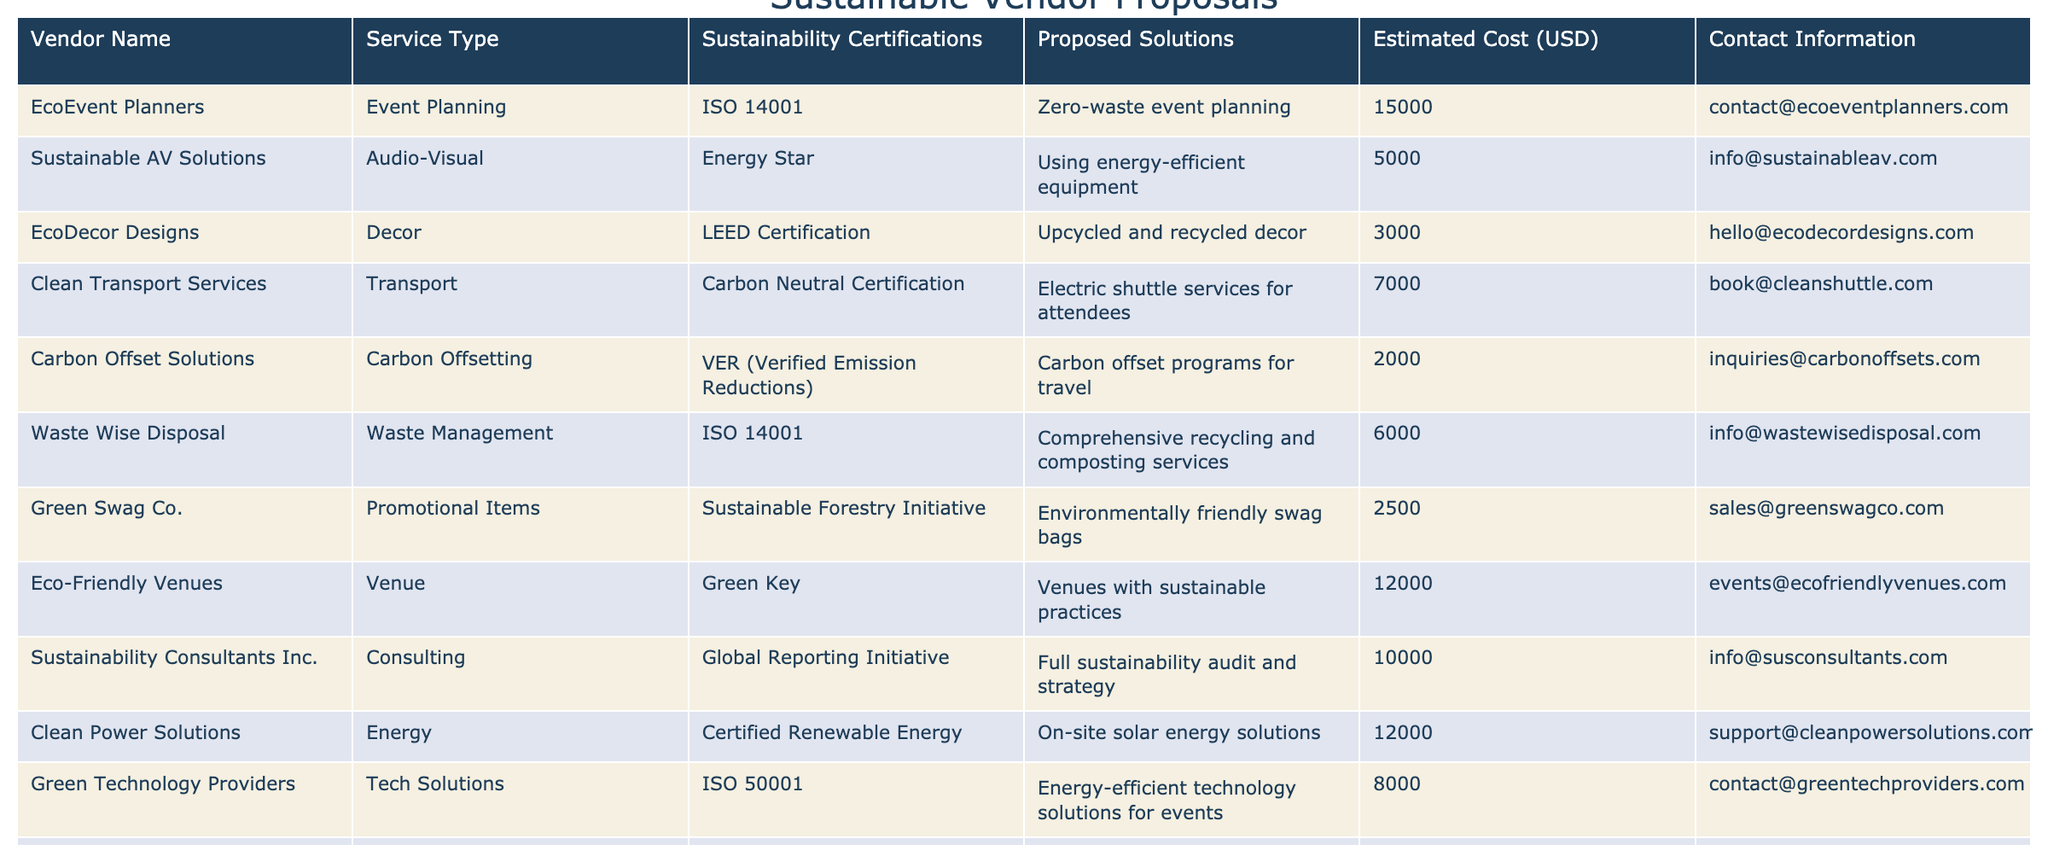What is the estimated cost of the EcoFriendly Venues service? In the table, I find the row for Eco-Friendly Venues and see the estimated cost is listed as 12000 USD.
Answer: 12000 USD What certifications does Waste Wise Disposal hold? By examining the Waste Wise Disposal row in the table, I find that the sustainability certification listed is ISO 14001.
Answer: ISO 14001 Which vendor offers services for carbon offsetting and what is their estimated cost? I look for the vendor that provides carbon offsetting services in the table, which is Carbon Offset Solutions, and their estimated cost is 2000 USD.
Answer: 2000 USD How many vendors offer transport services, and what are their names? I count the rows that have "Transport" under the Service Type. The only vendor listed is Clean Transport Services, which counts as one.
Answer: 1 vendor What is the total estimated cost of vendor proposals that offer event planning services? I find EcoEvent Planners listed under event planning with an estimated cost of 15000 USD. I will sum this up since it is the only vendor in this category. Total = 15000.
Answer: 15000 USD Which vendor provides electric shuttle services and what certification do they have? The table indicates that Clean Transport Services supplies electric shuttle services, and they possess the Carbon Neutral Certification.
Answer: Clean Transport Services; Carbon Neutral Certification Is there a vendor that specializes in promotional items? I look for the Service Type 'Promotional Items' and find Green Swag Co. listed, confirming that such a vendor exists.
Answer: Yes What is the median estimated cost of all the vendors listed in the table? I list all the estimated costs: 15000, 5000, 3000, 7000, 2000, 6000, 2500, 12000, 10000, 12000, 8000, 3000, 4000. Sorting these gives: 2000, 2500, 3000, 3000, 4000, 5000, 6000, 7000, 8000, 10000, 12000, 12000, 15000. The median (middle value) of the 13 values is 6000.
Answer: 6000 USD Which vendors have sustainability certifications that are ISO standards? I look at the sustainability certifications and find that Waste Wise Disposal (ISO 14001) and Green Technology Providers (ISO 50001) hold ISO certifications.
Answer: Waste Wise Disposal; Green Technology Providers What is the total cost of all vendors that provide media services? I check the table and see that Ethical Media Partners is the only vendor offering media services with a cost of 4000 USD. Therefore, the total cost is 4000.
Answer: 4000 USD Which vendor has the highest estimated cost and what service do they provide? I review the estimated costs and see that EcoEvent Planners has the highest estimated cost of 15000 USD, and they provide event planning services.
Answer: EcoEvent Planners; Event Planning 